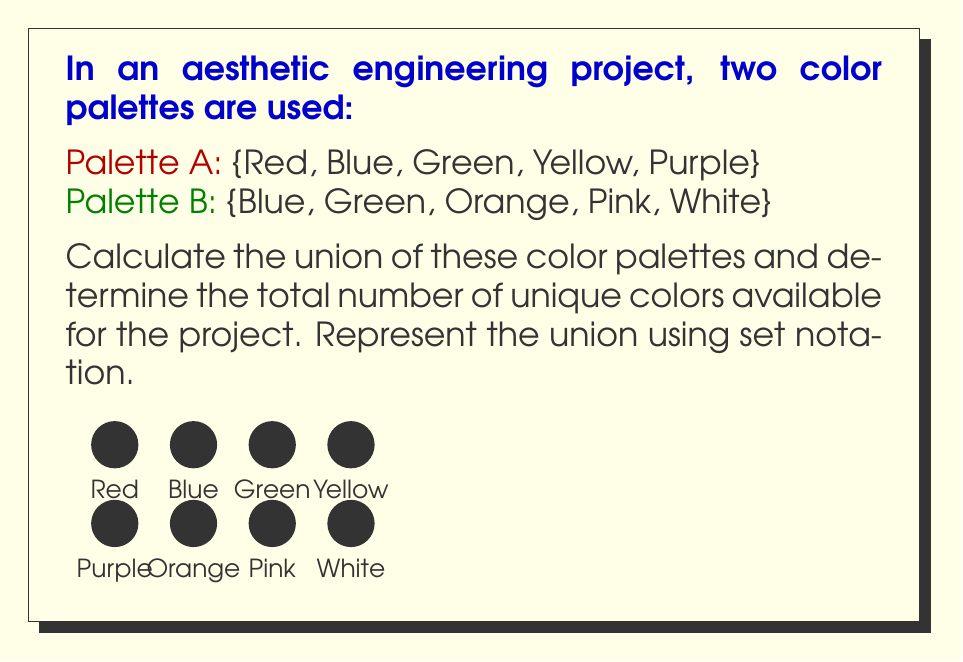Provide a solution to this math problem. To solve this problem, we'll follow these steps:

1. Identify the elements in each set:
   Palette A = {Red, Blue, Green, Yellow, Purple}
   Palette B = {Blue, Green, Orange, Pink, White}

2. Recall the definition of union:
   The union of two sets A and B, denoted by $A \cup B$, is the set of all elements that are in A, or in B, or in both.

3. List all unique elements from both sets:
   $A \cup B$ = {Red, Blue, Green, Yellow, Purple, Orange, Pink, White}

4. Count the number of elements in the union:
   $|A \cup B| = 8$

5. Represent the union using set notation:
   $A \cup B = \{x : x \in A \text{ or } x \in B\}$

The union operation combines all unique colors from both palettes, eliminating duplicates (Blue and Green in this case).
Answer: $A \cup B = \{Red, Blue, Green, Yellow, Purple, Orange, Pink, White\}$; $|A \cup B| = 8$ 